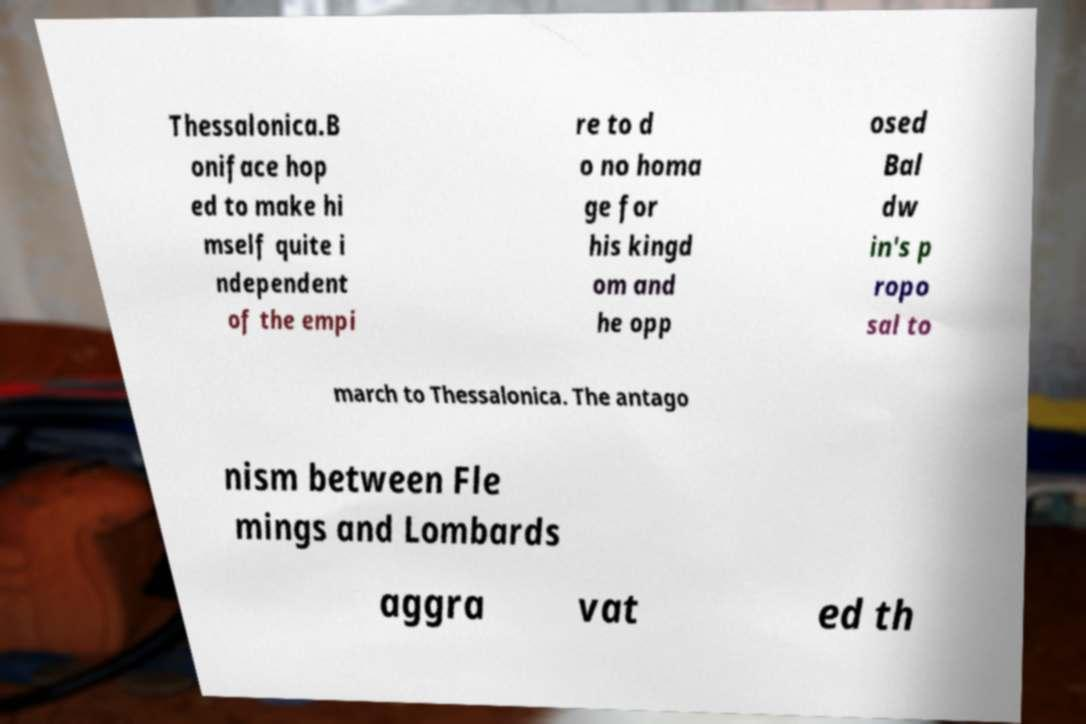Could you extract and type out the text from this image? Thessalonica.B oniface hop ed to make hi mself quite i ndependent of the empi re to d o no homa ge for his kingd om and he opp osed Bal dw in's p ropo sal to march to Thessalonica. The antago nism between Fle mings and Lombards aggra vat ed th 